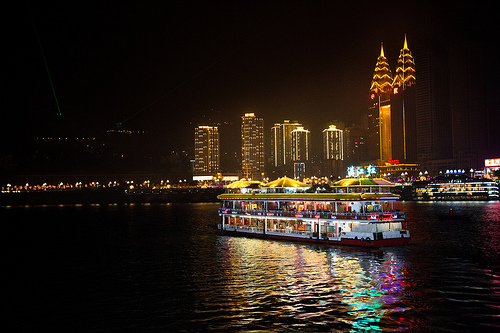Describe the scene depicted in the image. The image depicts a nighttime scene in a bustling city. A brightly lit ferry or pleasure boat is cruising on the water, reflecting the lights off its surface. The background showcases tall, illuminated buildings, likely office towers or luxury apartments, creating a striking city skyline. What kind of activities could be happening on the boat? The boat could be hosting a variety of activities such as a dinner cruise, a sightseeing tour, or even a private event or party. Given the vibrant lighting and festive atmosphere, it is likely that passengers are enjoying food, drinks, and possibly some entertainment while taking in the beautiful night views. 